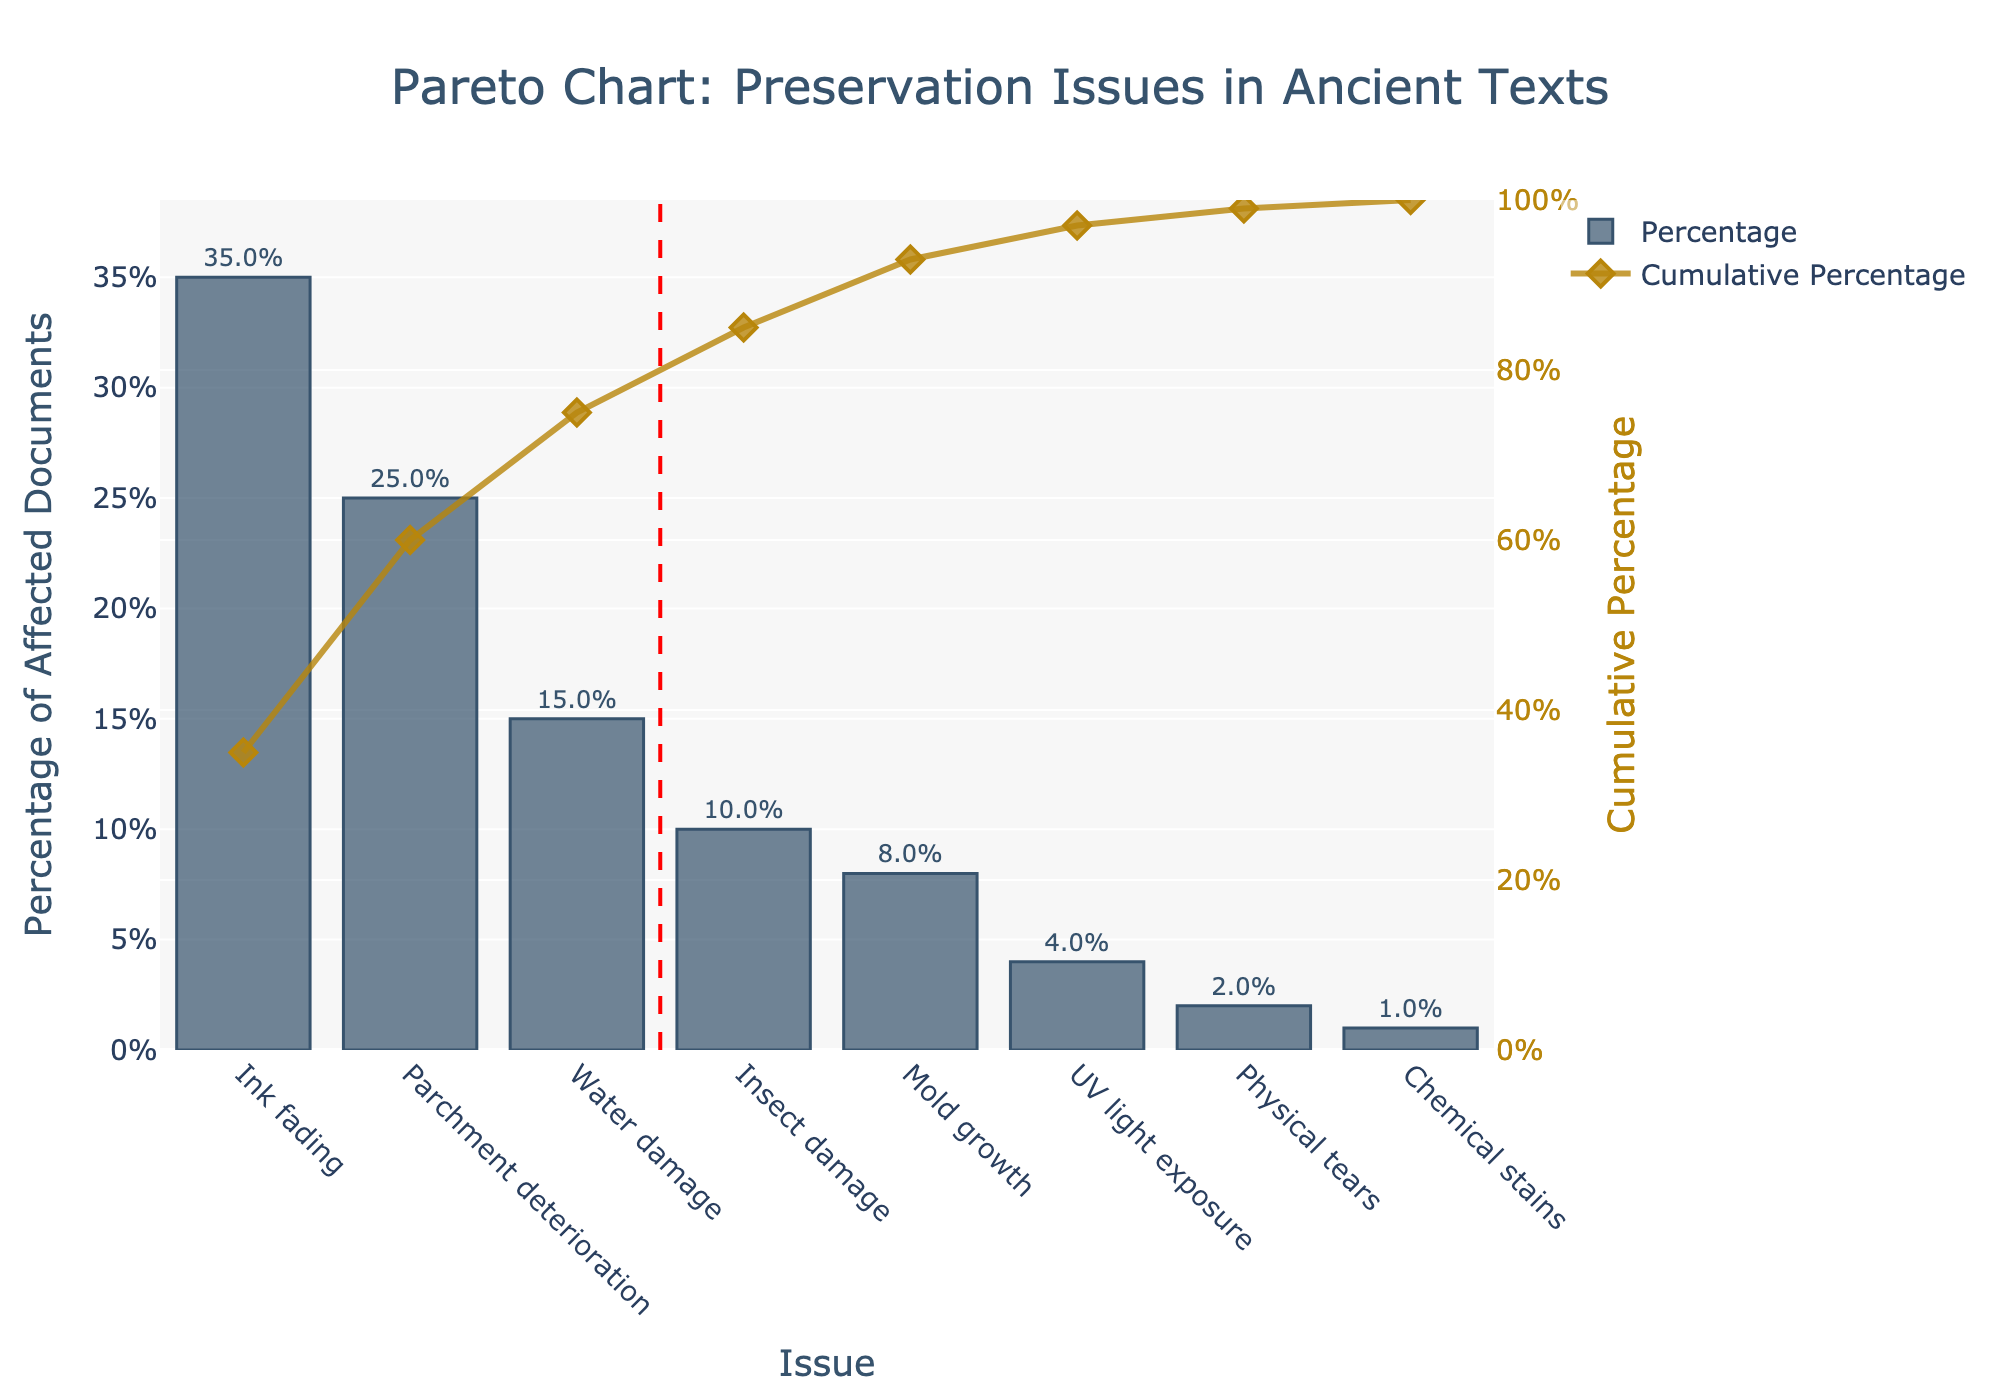What is the title of the chart? The title of the chart is usually positioned at the top and is written in a larger font size compared to other texts. It helps in understanding the overall context of the figure.
Answer: Pareto Chart: Preservation Issues in Ancient Texts Which preservation issue affects the highest percentage of documents? To find the issue that affects the highest percentage of documents, look for the tallest bar in the bar chart.
Answer: Ink fading What is the percentage of documents affected by physical tears? Look for the bar labeled "Physical tears" and note the percentage value annotated above it.
Answer: 2% How many preservation issues account for approximately 80% of the cumulative percentage? Locate the 80% cumulative line on the secondary y-axis (right side) and count the number of issues from the left until this line is reached.
Answer: Three issues What is the cumulative percentage for ink fading and parchment deterioration combined? Identify the bars for "Ink fading" and "Parchment deterioration," then sum their percentage values from the cumulative percentage line chart.
Answer: 60% Which preservation issue has the smallest impact on ancient texts according to the chart? Find the shortest bar in the chart, which will represent the issue affecting the smallest percentage of documents.
Answer: Chemical stains How does the impact of water damage compare to insect damage? Compare the heights of the bars for "Water damage" and "Insect damage" to see which is higher.
Answer: Water damage is greater What is the cumulative percentage after including all issues displayed in the chart? Look at the last cumulative percentage point on the line chart. The last point should approach 100%.
Answer: 100% If we address issues causing the top 50% of the damage, which issues would we focus on? Identify the cumulative percentage value closest to 50% and count the number of issues up to that point. The main issues must be addressed as "Ink fading".
Answer: Ink fading and Parchment deterioration What observation can you make about the distribution of preservation issues using this Pareto chart? By examining the heights of the bars and the slope of the cumulative percentage line, we can infer how preservation issues are distributed. Specifically, a steep initial slope followed by a flatter tail indicates that a few issues cause most of the damage.
Answer: A few issues cause most of the damage 